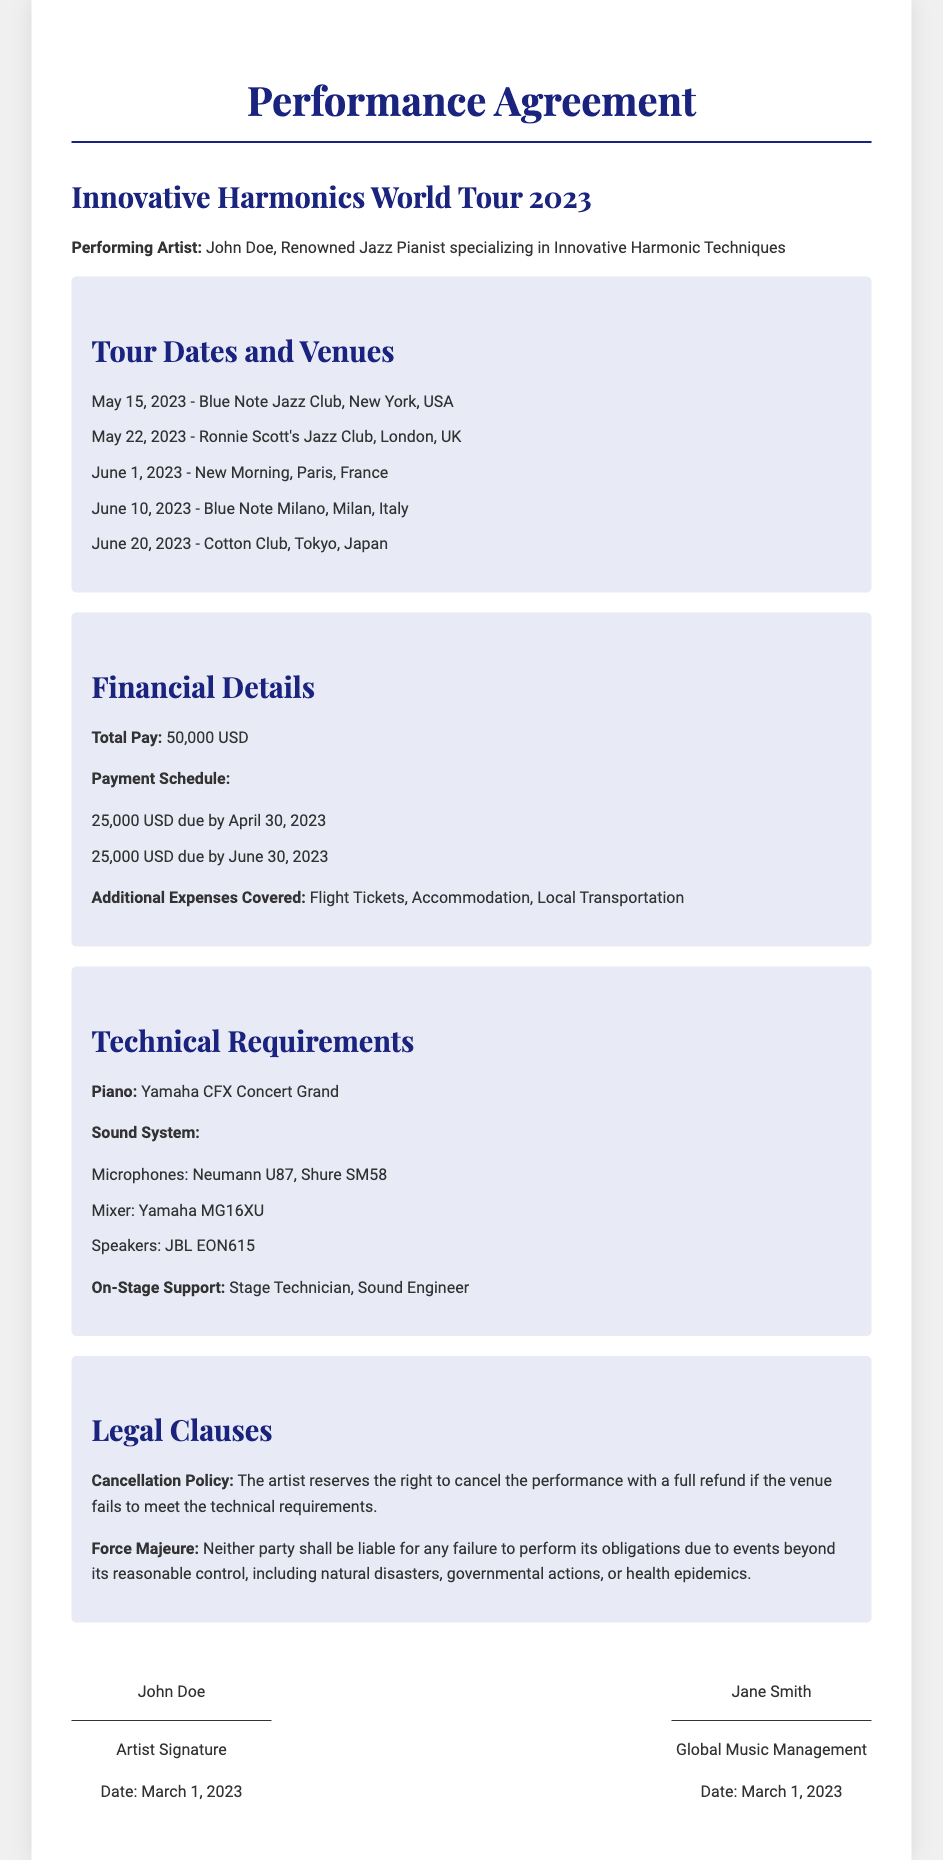What is the name of the performing artist? The performing artist is mentioned at the top of the document as John Doe.
Answer: John Doe What is the total payment amount? The total payment amount is specified in the financial details section as 50,000 USD.
Answer: 50,000 USD When is the performance at the Blue Note Jazz Club scheduled? The date for the Blue Note Jazz Club performance is listed in the tour details section as May 15, 2023.
Answer: May 15, 2023 What is included in the additional expenses covered? The additional expenses covered are listed as Flight Tickets, Accommodation, and Local Transportation.
Answer: Flight Tickets, Accommodation, Local Transportation What type of piano is required for the performance? The required piano type is specified in the technical requirements section as Yamaha CFX Concert Grand.
Answer: Yamaha CFX Concert Grand How much is due by April 30, 2023? The payment schedule mentions that 25,000 USD is due by April 30, 2023.
Answer: 25,000 USD What is the cancellation policy outlined in the contract? The cancellation policy states that the artist can cancel if the venue fails to meet the technical requirements.
Answer: Full refund if technical requirements are not met Which city will the performance take place after London? The next city following London in the tour details is Paris.
Answer: Paris 